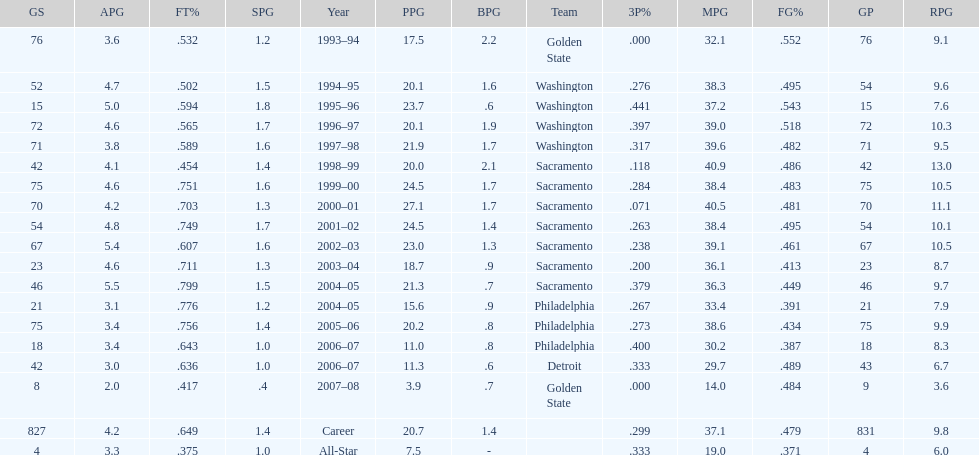How many seasons did webber average over 20 points per game (ppg)? 11. 